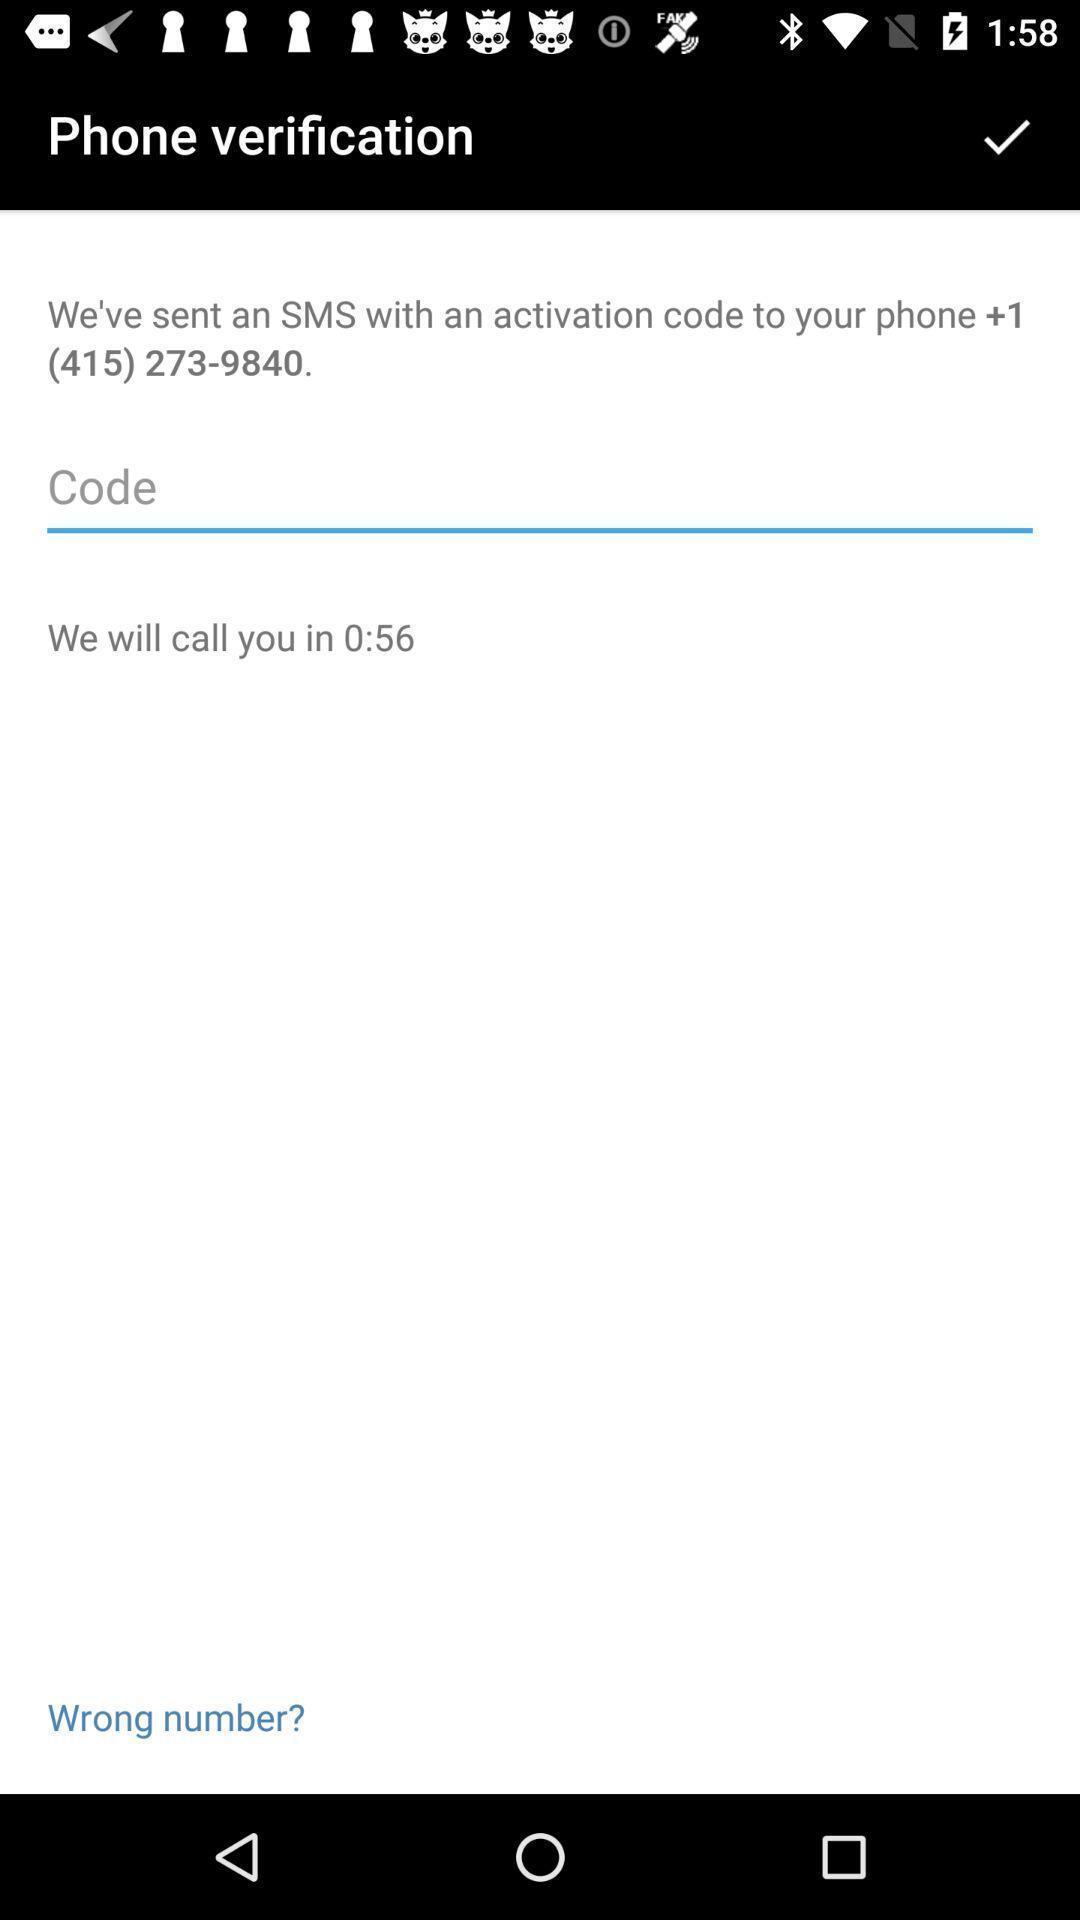Describe this image in words. Screen shows verification page. 